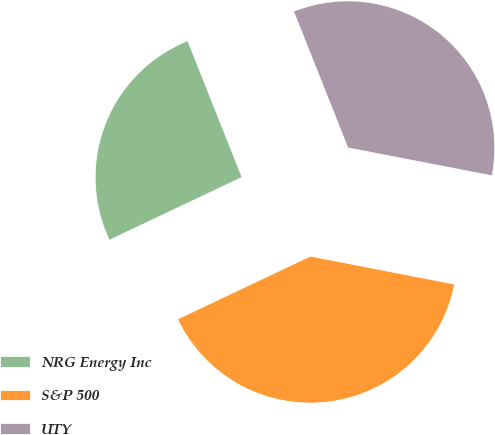Convert chart to OTSL. <chart><loc_0><loc_0><loc_500><loc_500><pie_chart><fcel>NRG Energy Inc<fcel>S&P 500<fcel>UTY<nl><fcel>26.02%<fcel>39.91%<fcel>34.07%<nl></chart> 